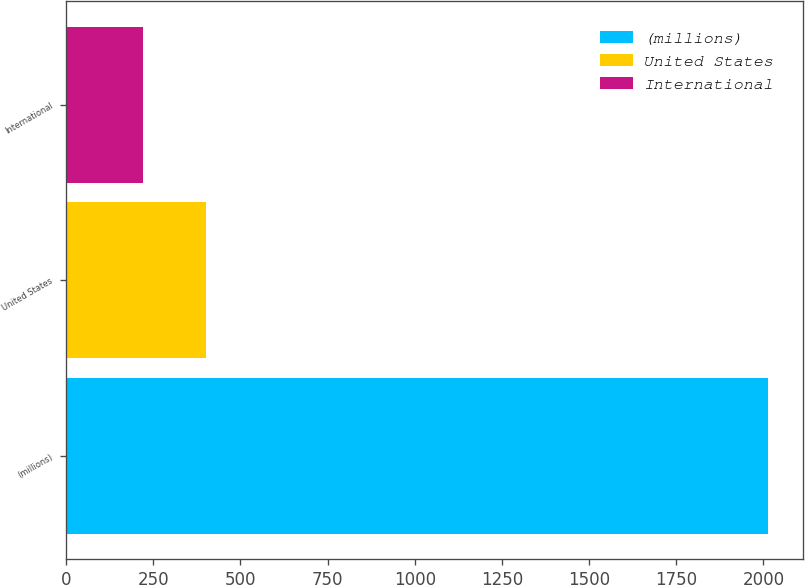<chart> <loc_0><loc_0><loc_500><loc_500><bar_chart><fcel>(millions)<fcel>United States<fcel>International<nl><fcel>2014<fcel>400.48<fcel>221.2<nl></chart> 